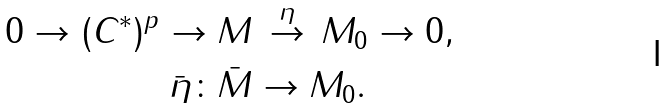<formula> <loc_0><loc_0><loc_500><loc_500>0 \to ( C ^ { * } ) ^ { p } \to M & \, \overset { \eta } \to \, M _ { 0 } \to 0 , \\ \bar { \eta } \colon \bar { M } & \to M _ { 0 } .</formula> 